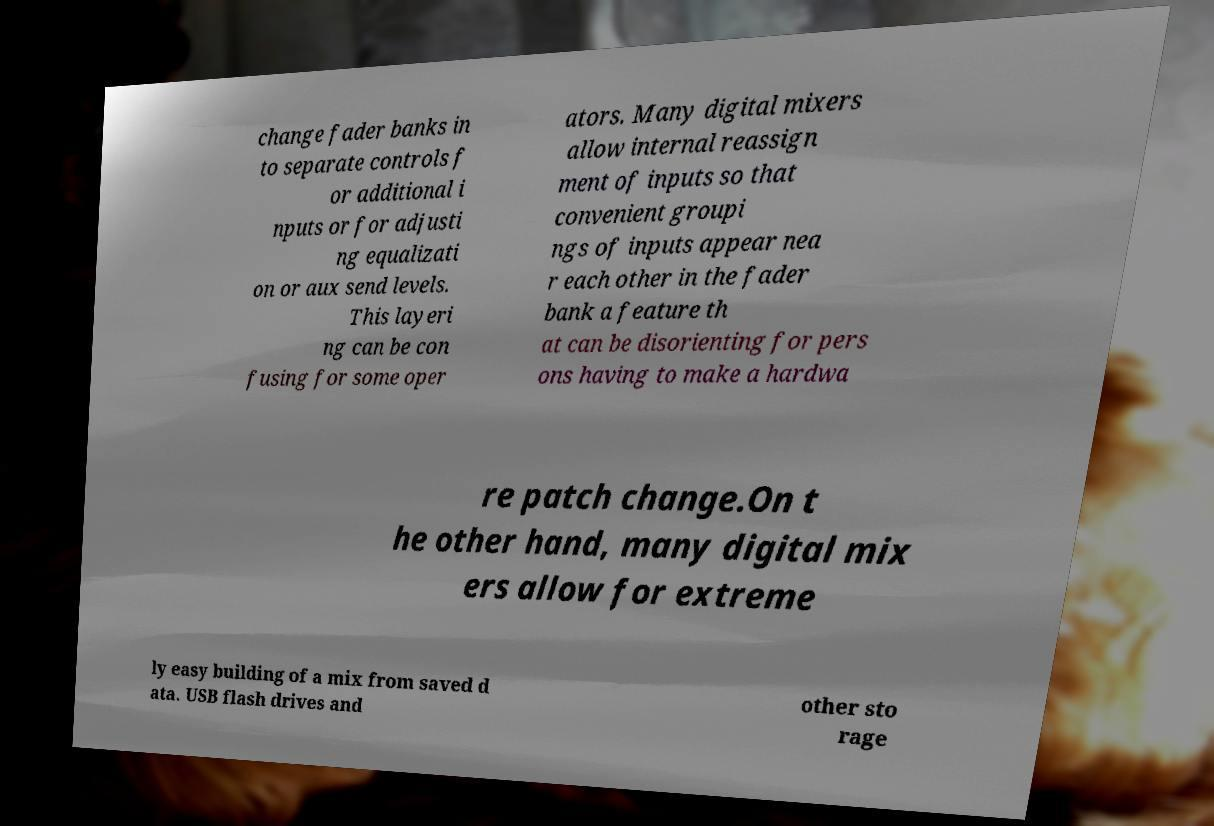I need the written content from this picture converted into text. Can you do that? change fader banks in to separate controls f or additional i nputs or for adjusti ng equalizati on or aux send levels. This layeri ng can be con fusing for some oper ators. Many digital mixers allow internal reassign ment of inputs so that convenient groupi ngs of inputs appear nea r each other in the fader bank a feature th at can be disorienting for pers ons having to make a hardwa re patch change.On t he other hand, many digital mix ers allow for extreme ly easy building of a mix from saved d ata. USB flash drives and other sto rage 